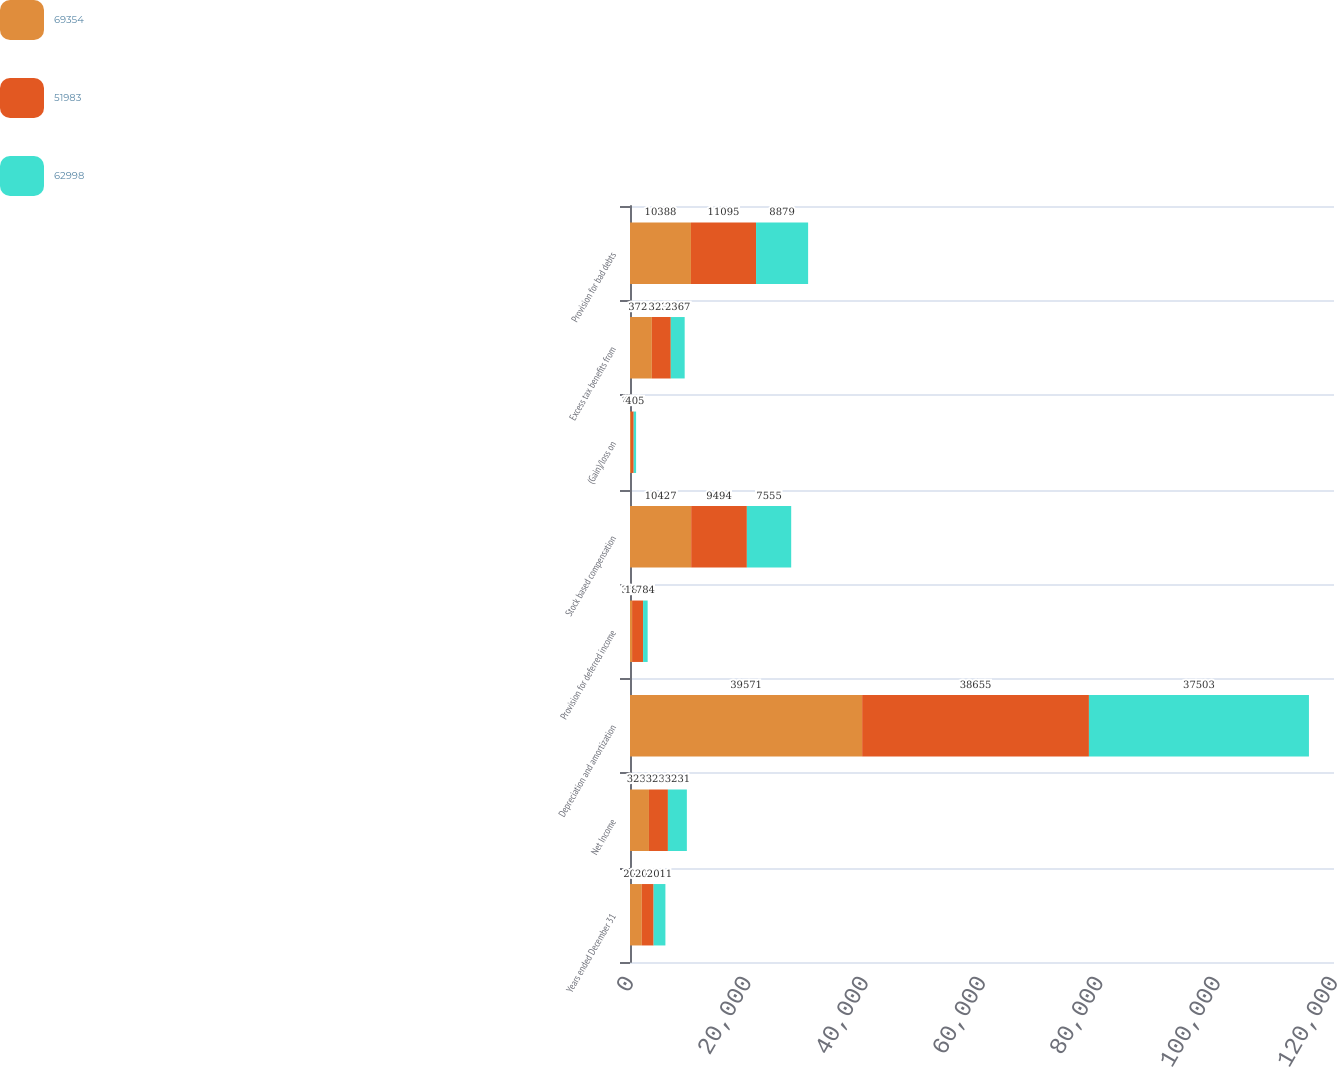Convert chart to OTSL. <chart><loc_0><loc_0><loc_500><loc_500><stacked_bar_chart><ecel><fcel>Years ended December 31<fcel>Net Income<fcel>Depreciation and amortization<fcel>Provision for deferred income<fcel>Stock based compensation<fcel>(Gain)/loss on<fcel>Excess tax benefits from<fcel>Provision for bad debts<nl><fcel>69354<fcel>2013<fcel>3231<fcel>39571<fcel>356<fcel>10427<fcel>165<fcel>3722<fcel>10388<nl><fcel>51983<fcel>2012<fcel>3231<fcel>38655<fcel>1870<fcel>9494<fcel>468<fcel>3231<fcel>11095<nl><fcel>62998<fcel>2011<fcel>3231<fcel>37503<fcel>784<fcel>7555<fcel>405<fcel>2367<fcel>8879<nl></chart> 